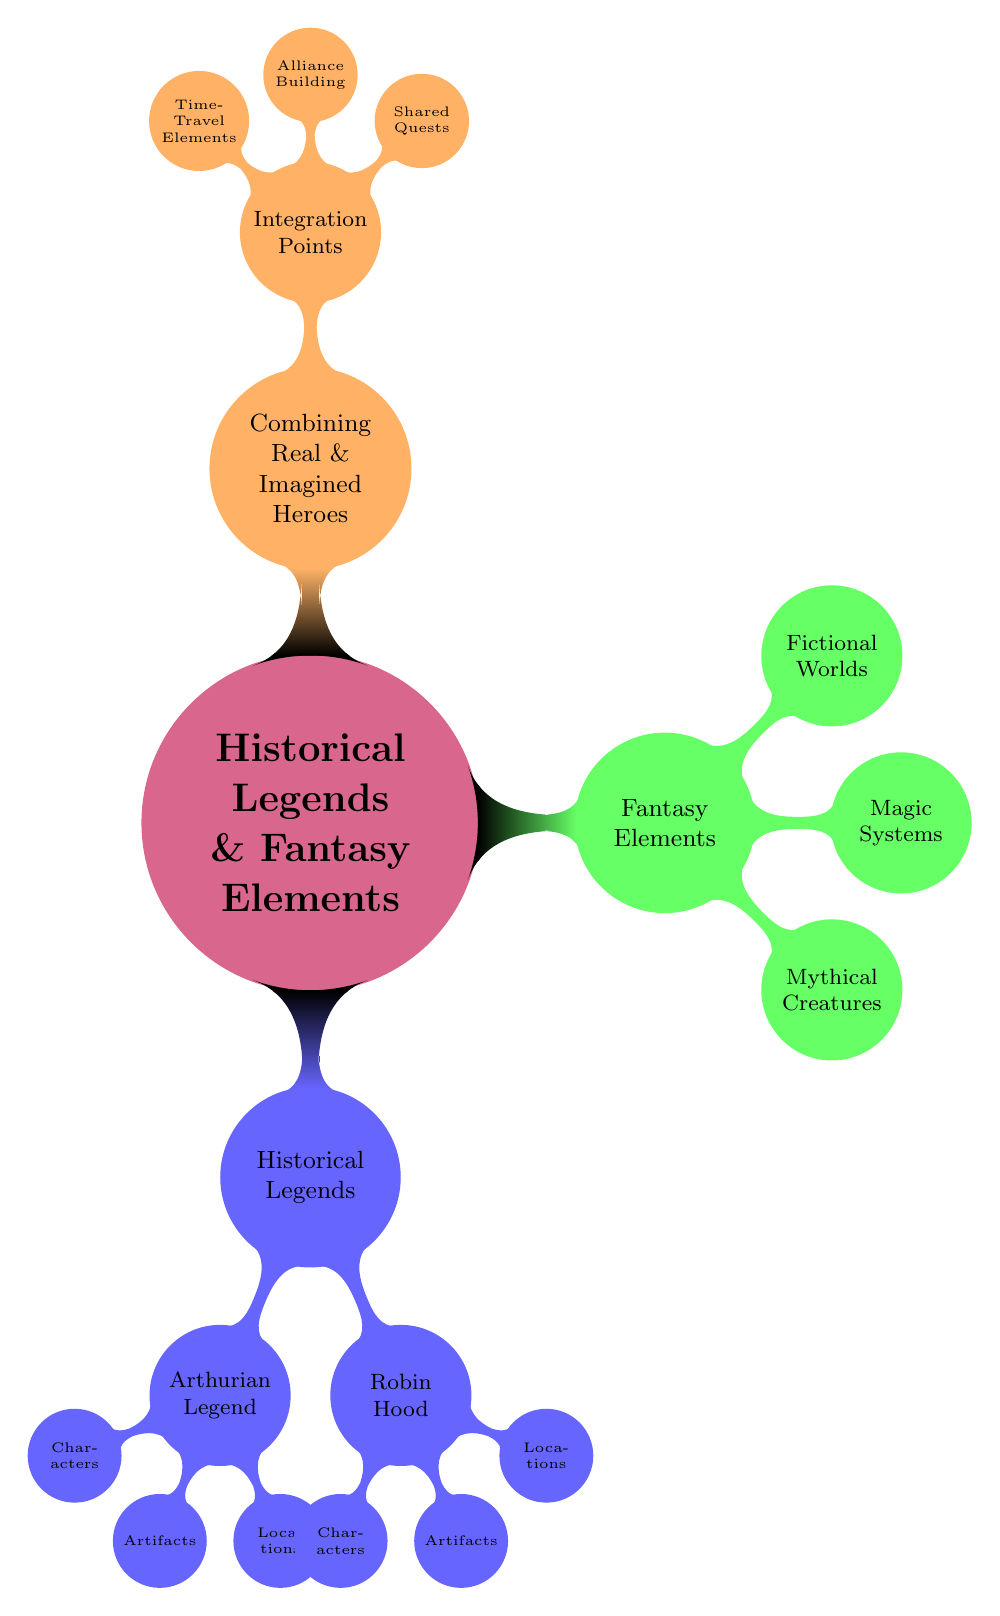What are the two main categories represented in the diagram? The diagram consists of three main categories, but the two focused are "Historical Legends" and "Fantasy Elements." Both categories represent distinct aspects of blending real and imagined heroes.
Answer: Historical Legends, Fantasy Elements How many characters are listed under the Arthurian Legend? There are two characters in the Arthurian Legend: King Arthur and Merlin. This is found directly under the node for Arthurian Legend.
Answer: 2 What is one of the artifacts associated with Robin Hood? One of the artifacts associated with Robin Hood mentioned in the diagram is the Longbow. This artifact is explicitly stated under the Robin Hood node.
Answer: Longbow Which mythical creature is included in the Fantasy Elements section? The diagram includes Dragons as one of the mythical creatures in the Fantasy Elements section. This is clearly listed under the Mythical Creatures node.
Answer: Dragons What is the shared quest mentioned in the Integration Points under Combining Real & Imagined Heroes? The shared quest noted in the Integration Points is the Quest for the Holy Grail, which blends elements from both historical and fantasy narratives.
Answer: Quest for Holy Grail How many locations are mentioned under Arthurian Legend? Under Arthurian Legend, there are two locations: Camelot and Avalon, which are both specified in the Locations node.
Answer: 2 What type of magic is listed in the Fantasy Elements section? The diagram lists Elemental Magic as one type of magic in the Fantasy Elements section. This is specifically mentioned under the Magic Systems node.
Answer: Elemental Magic How many integration points are specified for combining real and imagined heroes? There are three integration points specified under the Combining Real & Imagined Heroes node: Shared Quests, Alliance Building, and Time-Travel Elements. This total is derived from counting the child nodes.
Answer: 3 